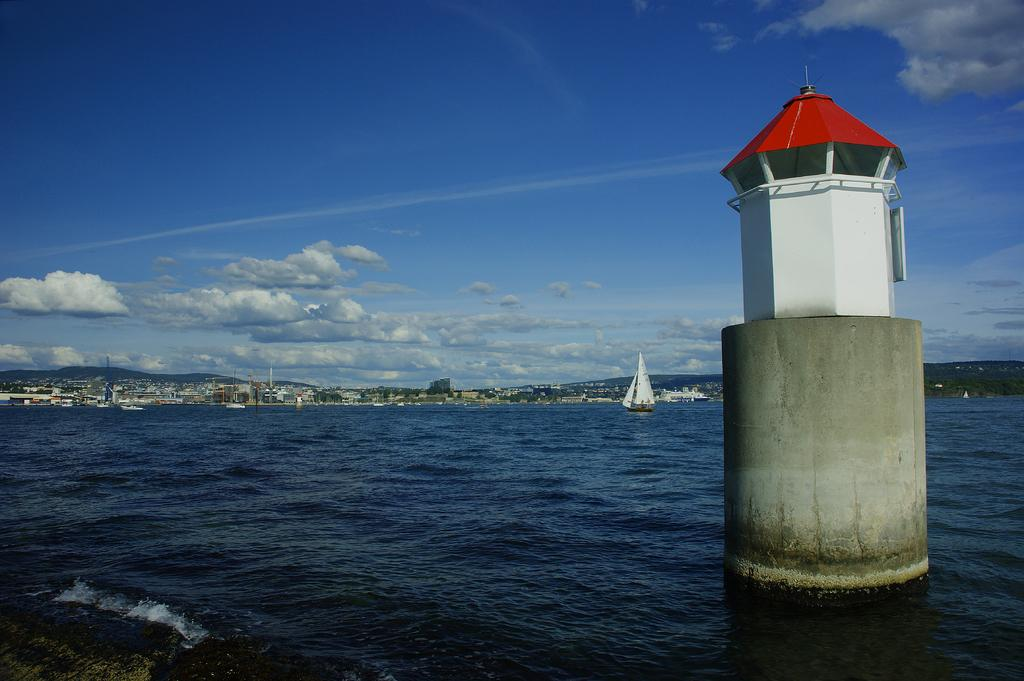What type of vehicles are in the image? There are boats in the image. Where are the boats located? The boats are on the sea. What structure can be seen in the image? There is a lighthouse in the image. What type of landscape is visible in the background of the image? There are buildings, a mountain, and the sky visible in the background of the image. How many years does it take for the mountain to grow in the image? The image does not depict the growth of the mountain over time, so it is not possible to determine the number of years it takes for the mountain to grow. 